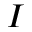Convert formula to latex. <formula><loc_0><loc_0><loc_500><loc_500>I</formula> 